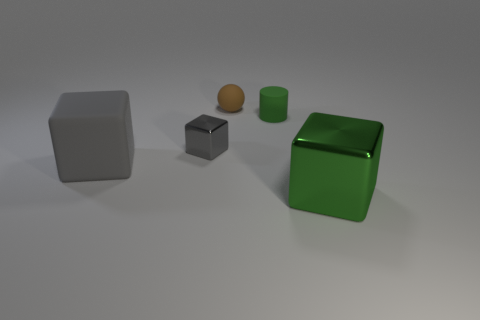Subtract all metal cubes. How many cubes are left? 1 Subtract all cylinders. How many objects are left? 4 Subtract 1 balls. How many balls are left? 0 Add 1 large red shiny cylinders. How many large red shiny cylinders exist? 1 Add 4 big blocks. How many objects exist? 9 Subtract all green cubes. How many cubes are left? 2 Subtract 0 blue spheres. How many objects are left? 5 Subtract all cyan cylinders. Subtract all gray spheres. How many cylinders are left? 1 Subtract all yellow balls. How many yellow cylinders are left? 0 Subtract all big blocks. Subtract all small cylinders. How many objects are left? 2 